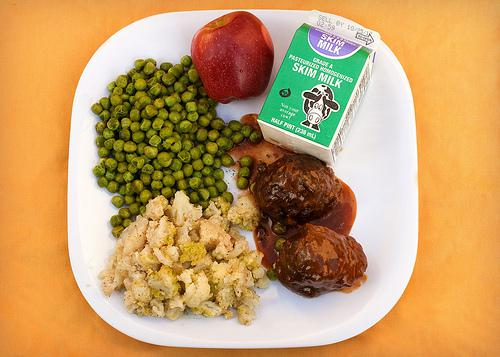Question: what is on the plate?
Choices:
A. A used napkin.
B. Silverware.
C. Placecard.
D. Food.
Answer with the letter. Answer: D Question: what type of milk is in the carton?
Choices:
A. Skim.
B. Chocolate.
C. Curdled.
D. Thick.
Answer with the letter. Answer: A 